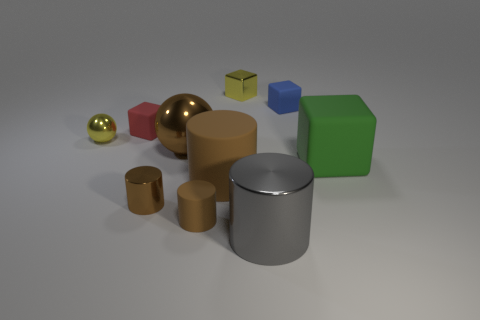Subtract all gray spheres. How many brown cylinders are left? 3 Subtract 1 blocks. How many blocks are left? 3 Subtract all cubes. How many objects are left? 6 Add 2 brown objects. How many brown objects exist? 6 Subtract 1 blue blocks. How many objects are left? 9 Subtract all large blocks. Subtract all tiny gray spheres. How many objects are left? 9 Add 4 brown things. How many brown things are left? 8 